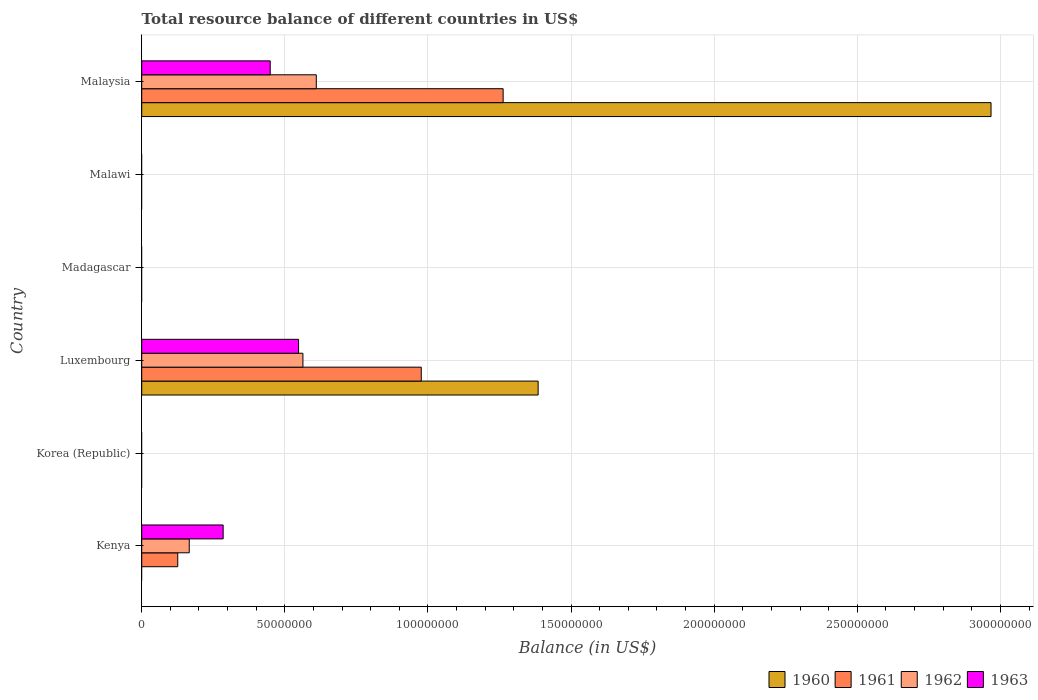Are the number of bars per tick equal to the number of legend labels?
Provide a short and direct response. No. How many bars are there on the 4th tick from the top?
Ensure brevity in your answer.  4. How many bars are there on the 5th tick from the bottom?
Provide a succinct answer. 0. What is the label of the 4th group of bars from the top?
Offer a terse response. Luxembourg. In how many cases, is the number of bars for a given country not equal to the number of legend labels?
Your response must be concise. 4. What is the total resource balance in 1960 in Kenya?
Ensure brevity in your answer.  0. Across all countries, what is the maximum total resource balance in 1963?
Offer a very short reply. 5.48e+07. Across all countries, what is the minimum total resource balance in 1963?
Provide a short and direct response. 0. In which country was the total resource balance in 1962 maximum?
Your answer should be very brief. Malaysia. What is the total total resource balance in 1960 in the graph?
Your answer should be very brief. 4.35e+08. What is the difference between the total resource balance in 1962 in Kenya and that in Luxembourg?
Your answer should be very brief. -3.97e+07. What is the difference between the total resource balance in 1962 in Malaysia and the total resource balance in 1960 in Kenya?
Offer a terse response. 6.10e+07. What is the average total resource balance in 1963 per country?
Your answer should be very brief. 2.14e+07. What is the difference between the total resource balance in 1961 and total resource balance in 1963 in Malaysia?
Ensure brevity in your answer.  8.14e+07. What is the ratio of the total resource balance in 1963 in Kenya to that in Luxembourg?
Make the answer very short. 0.52. What is the difference between the highest and the second highest total resource balance in 1961?
Your response must be concise. 2.86e+07. What is the difference between the highest and the lowest total resource balance in 1960?
Provide a succinct answer. 2.97e+08. Is it the case that in every country, the sum of the total resource balance in 1963 and total resource balance in 1960 is greater than the sum of total resource balance in 1962 and total resource balance in 1961?
Your answer should be compact. No. How many bars are there?
Offer a terse response. 11. Are all the bars in the graph horizontal?
Give a very brief answer. Yes. What is the difference between two consecutive major ticks on the X-axis?
Keep it short and to the point. 5.00e+07. Does the graph contain grids?
Ensure brevity in your answer.  Yes. How are the legend labels stacked?
Your answer should be very brief. Horizontal. What is the title of the graph?
Keep it short and to the point. Total resource balance of different countries in US$. Does "1961" appear as one of the legend labels in the graph?
Offer a very short reply. Yes. What is the label or title of the X-axis?
Keep it short and to the point. Balance (in US$). What is the Balance (in US$) in 1961 in Kenya?
Make the answer very short. 1.26e+07. What is the Balance (in US$) of 1962 in Kenya?
Your answer should be very brief. 1.66e+07. What is the Balance (in US$) in 1963 in Kenya?
Provide a short and direct response. 2.84e+07. What is the Balance (in US$) in 1960 in Korea (Republic)?
Your response must be concise. 0. What is the Balance (in US$) of 1961 in Korea (Republic)?
Your answer should be compact. 0. What is the Balance (in US$) in 1962 in Korea (Republic)?
Offer a very short reply. 0. What is the Balance (in US$) in 1963 in Korea (Republic)?
Your response must be concise. 0. What is the Balance (in US$) in 1960 in Luxembourg?
Provide a succinct answer. 1.38e+08. What is the Balance (in US$) of 1961 in Luxembourg?
Make the answer very short. 9.77e+07. What is the Balance (in US$) in 1962 in Luxembourg?
Your response must be concise. 5.63e+07. What is the Balance (in US$) in 1963 in Luxembourg?
Make the answer very short. 5.48e+07. What is the Balance (in US$) in 1962 in Madagascar?
Ensure brevity in your answer.  0. What is the Balance (in US$) in 1963 in Madagascar?
Offer a very short reply. 0. What is the Balance (in US$) of 1960 in Malawi?
Provide a short and direct response. 0. What is the Balance (in US$) of 1963 in Malawi?
Make the answer very short. 0. What is the Balance (in US$) of 1960 in Malaysia?
Provide a succinct answer. 2.97e+08. What is the Balance (in US$) in 1961 in Malaysia?
Make the answer very short. 1.26e+08. What is the Balance (in US$) in 1962 in Malaysia?
Offer a terse response. 6.10e+07. What is the Balance (in US$) of 1963 in Malaysia?
Offer a terse response. 4.49e+07. Across all countries, what is the maximum Balance (in US$) of 1960?
Offer a terse response. 2.97e+08. Across all countries, what is the maximum Balance (in US$) of 1961?
Ensure brevity in your answer.  1.26e+08. Across all countries, what is the maximum Balance (in US$) in 1962?
Offer a terse response. 6.10e+07. Across all countries, what is the maximum Balance (in US$) of 1963?
Offer a terse response. 5.48e+07. Across all countries, what is the minimum Balance (in US$) in 1960?
Your answer should be compact. 0. Across all countries, what is the minimum Balance (in US$) of 1962?
Keep it short and to the point. 0. Across all countries, what is the minimum Balance (in US$) of 1963?
Your response must be concise. 0. What is the total Balance (in US$) in 1960 in the graph?
Offer a terse response. 4.35e+08. What is the total Balance (in US$) in 1961 in the graph?
Your answer should be very brief. 2.37e+08. What is the total Balance (in US$) in 1962 in the graph?
Ensure brevity in your answer.  1.34e+08. What is the total Balance (in US$) of 1963 in the graph?
Your answer should be very brief. 1.28e+08. What is the difference between the Balance (in US$) of 1961 in Kenya and that in Luxembourg?
Provide a succinct answer. -8.51e+07. What is the difference between the Balance (in US$) in 1962 in Kenya and that in Luxembourg?
Offer a very short reply. -3.97e+07. What is the difference between the Balance (in US$) of 1963 in Kenya and that in Luxembourg?
Ensure brevity in your answer.  -2.64e+07. What is the difference between the Balance (in US$) of 1961 in Kenya and that in Malaysia?
Provide a short and direct response. -1.14e+08. What is the difference between the Balance (in US$) of 1962 in Kenya and that in Malaysia?
Provide a short and direct response. -4.44e+07. What is the difference between the Balance (in US$) in 1963 in Kenya and that in Malaysia?
Keep it short and to the point. -1.64e+07. What is the difference between the Balance (in US$) of 1960 in Luxembourg and that in Malaysia?
Ensure brevity in your answer.  -1.58e+08. What is the difference between the Balance (in US$) of 1961 in Luxembourg and that in Malaysia?
Provide a succinct answer. -2.86e+07. What is the difference between the Balance (in US$) in 1962 in Luxembourg and that in Malaysia?
Your answer should be very brief. -4.67e+06. What is the difference between the Balance (in US$) of 1963 in Luxembourg and that in Malaysia?
Ensure brevity in your answer.  9.91e+06. What is the difference between the Balance (in US$) in 1961 in Kenya and the Balance (in US$) in 1962 in Luxembourg?
Offer a terse response. -4.37e+07. What is the difference between the Balance (in US$) in 1961 in Kenya and the Balance (in US$) in 1963 in Luxembourg?
Ensure brevity in your answer.  -4.22e+07. What is the difference between the Balance (in US$) of 1962 in Kenya and the Balance (in US$) of 1963 in Luxembourg?
Your answer should be very brief. -3.82e+07. What is the difference between the Balance (in US$) in 1961 in Kenya and the Balance (in US$) in 1962 in Malaysia?
Provide a short and direct response. -4.84e+07. What is the difference between the Balance (in US$) in 1961 in Kenya and the Balance (in US$) in 1963 in Malaysia?
Your answer should be very brief. -3.23e+07. What is the difference between the Balance (in US$) in 1962 in Kenya and the Balance (in US$) in 1963 in Malaysia?
Make the answer very short. -2.83e+07. What is the difference between the Balance (in US$) in 1960 in Luxembourg and the Balance (in US$) in 1961 in Malaysia?
Offer a terse response. 1.22e+07. What is the difference between the Balance (in US$) of 1960 in Luxembourg and the Balance (in US$) of 1962 in Malaysia?
Your answer should be compact. 7.75e+07. What is the difference between the Balance (in US$) in 1960 in Luxembourg and the Balance (in US$) in 1963 in Malaysia?
Your answer should be compact. 9.36e+07. What is the difference between the Balance (in US$) in 1961 in Luxembourg and the Balance (in US$) in 1962 in Malaysia?
Make the answer very short. 3.67e+07. What is the difference between the Balance (in US$) of 1961 in Luxembourg and the Balance (in US$) of 1963 in Malaysia?
Keep it short and to the point. 5.28e+07. What is the difference between the Balance (in US$) in 1962 in Luxembourg and the Balance (in US$) in 1963 in Malaysia?
Offer a terse response. 1.14e+07. What is the average Balance (in US$) of 1960 per country?
Give a very brief answer. 7.25e+07. What is the average Balance (in US$) of 1961 per country?
Make the answer very short. 3.94e+07. What is the average Balance (in US$) in 1962 per country?
Your answer should be compact. 2.23e+07. What is the average Balance (in US$) of 1963 per country?
Give a very brief answer. 2.14e+07. What is the difference between the Balance (in US$) of 1961 and Balance (in US$) of 1962 in Kenya?
Ensure brevity in your answer.  -4.02e+06. What is the difference between the Balance (in US$) of 1961 and Balance (in US$) of 1963 in Kenya?
Your response must be concise. -1.59e+07. What is the difference between the Balance (in US$) of 1962 and Balance (in US$) of 1963 in Kenya?
Offer a terse response. -1.18e+07. What is the difference between the Balance (in US$) of 1960 and Balance (in US$) of 1961 in Luxembourg?
Keep it short and to the point. 4.08e+07. What is the difference between the Balance (in US$) of 1960 and Balance (in US$) of 1962 in Luxembourg?
Give a very brief answer. 8.22e+07. What is the difference between the Balance (in US$) in 1960 and Balance (in US$) in 1963 in Luxembourg?
Ensure brevity in your answer.  8.37e+07. What is the difference between the Balance (in US$) in 1961 and Balance (in US$) in 1962 in Luxembourg?
Ensure brevity in your answer.  4.13e+07. What is the difference between the Balance (in US$) in 1961 and Balance (in US$) in 1963 in Luxembourg?
Offer a terse response. 4.29e+07. What is the difference between the Balance (in US$) of 1962 and Balance (in US$) of 1963 in Luxembourg?
Provide a short and direct response. 1.52e+06. What is the difference between the Balance (in US$) in 1960 and Balance (in US$) in 1961 in Malaysia?
Your response must be concise. 1.70e+08. What is the difference between the Balance (in US$) of 1960 and Balance (in US$) of 1962 in Malaysia?
Your answer should be compact. 2.36e+08. What is the difference between the Balance (in US$) in 1960 and Balance (in US$) in 1963 in Malaysia?
Provide a short and direct response. 2.52e+08. What is the difference between the Balance (in US$) in 1961 and Balance (in US$) in 1962 in Malaysia?
Offer a very short reply. 6.53e+07. What is the difference between the Balance (in US$) in 1961 and Balance (in US$) in 1963 in Malaysia?
Give a very brief answer. 8.14e+07. What is the difference between the Balance (in US$) in 1962 and Balance (in US$) in 1963 in Malaysia?
Make the answer very short. 1.61e+07. What is the ratio of the Balance (in US$) in 1961 in Kenya to that in Luxembourg?
Your answer should be compact. 0.13. What is the ratio of the Balance (in US$) in 1962 in Kenya to that in Luxembourg?
Keep it short and to the point. 0.29. What is the ratio of the Balance (in US$) in 1963 in Kenya to that in Luxembourg?
Make the answer very short. 0.52. What is the ratio of the Balance (in US$) of 1961 in Kenya to that in Malaysia?
Your response must be concise. 0.1. What is the ratio of the Balance (in US$) in 1962 in Kenya to that in Malaysia?
Make the answer very short. 0.27. What is the ratio of the Balance (in US$) in 1963 in Kenya to that in Malaysia?
Your answer should be compact. 0.63. What is the ratio of the Balance (in US$) of 1960 in Luxembourg to that in Malaysia?
Offer a very short reply. 0.47. What is the ratio of the Balance (in US$) of 1961 in Luxembourg to that in Malaysia?
Your answer should be very brief. 0.77. What is the ratio of the Balance (in US$) of 1962 in Luxembourg to that in Malaysia?
Your answer should be compact. 0.92. What is the ratio of the Balance (in US$) in 1963 in Luxembourg to that in Malaysia?
Ensure brevity in your answer.  1.22. What is the difference between the highest and the second highest Balance (in US$) in 1961?
Offer a very short reply. 2.86e+07. What is the difference between the highest and the second highest Balance (in US$) of 1962?
Your answer should be compact. 4.67e+06. What is the difference between the highest and the second highest Balance (in US$) in 1963?
Ensure brevity in your answer.  9.91e+06. What is the difference between the highest and the lowest Balance (in US$) of 1960?
Provide a short and direct response. 2.97e+08. What is the difference between the highest and the lowest Balance (in US$) of 1961?
Offer a very short reply. 1.26e+08. What is the difference between the highest and the lowest Balance (in US$) in 1962?
Make the answer very short. 6.10e+07. What is the difference between the highest and the lowest Balance (in US$) in 1963?
Keep it short and to the point. 5.48e+07. 